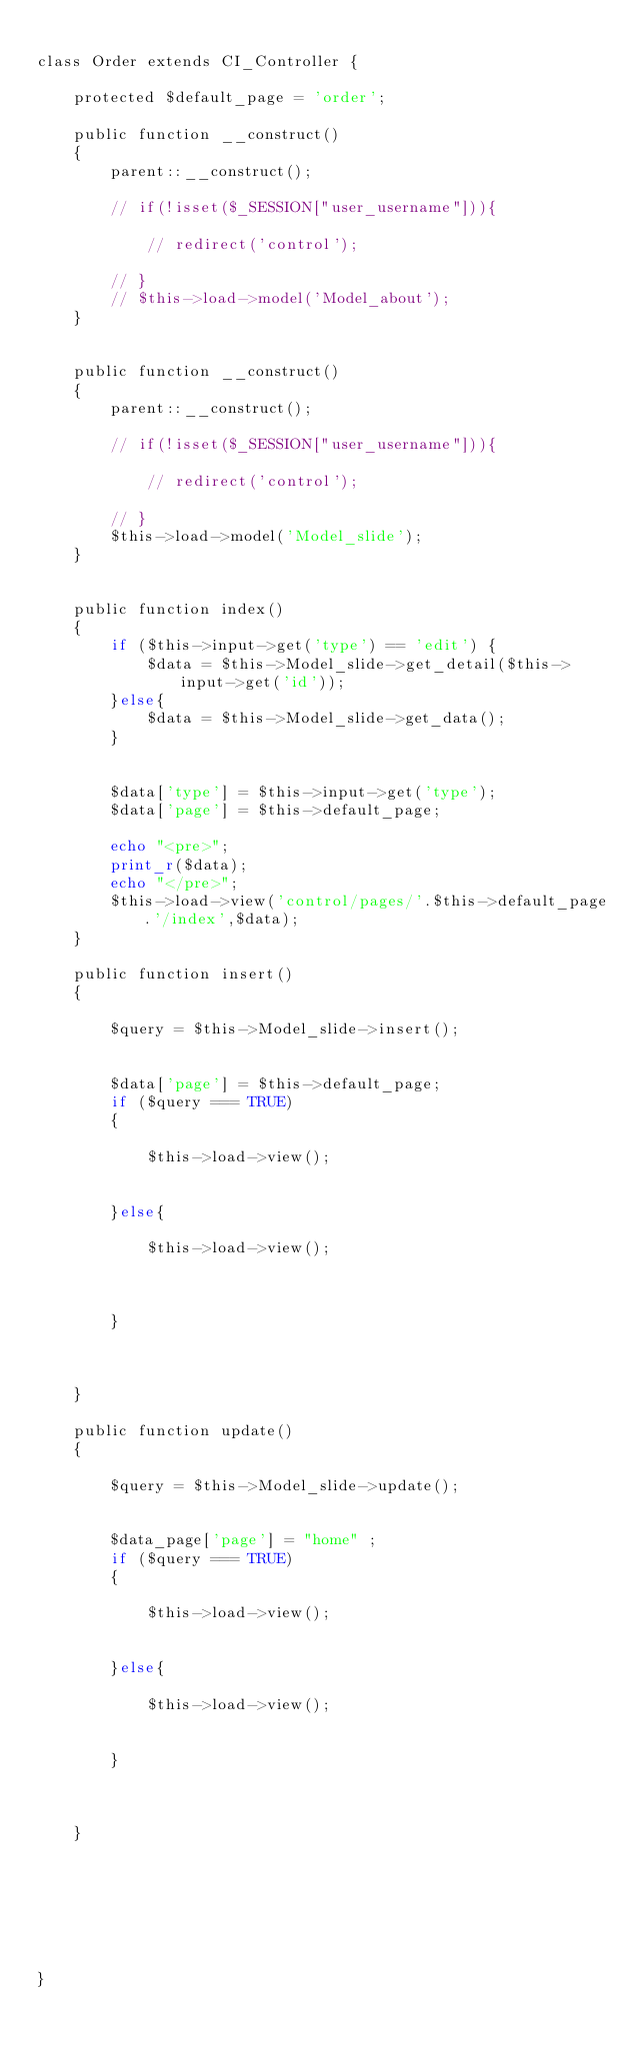Convert code to text. <code><loc_0><loc_0><loc_500><loc_500><_PHP_>
class Order extends CI_Controller {
	
	protected $default_page = 'order';

	public function __construct()
	{
		parent::__construct();		
		
		// if(!isset($_SESSION["user_username"])){

			// redirect('control');  

		// }
		// $this->load->model('Model_about');	
	}

	
	public function __construct()
	{
		parent::__construct();		
		
		// if(!isset($_SESSION["user_username"])){

			// redirect('control');  

		// }
		$this->load->model('Model_slide');	
	}

	
	public function index()
	{	
		if ($this->input->get('type') == 'edit') {
			$data = $this->Model_slide->get_detail($this->input->get('id'));
		}else{
			$data = $this->Model_slide->get_data();
		}

		
		$data['type'] = $this->input->get('type');
		$data['page'] = $this->default_page;		

		echo "<pre>";
		print_r($data);
		echo "</pre>";
		$this->load->view('control/pages/'.$this->default_page.'/index',$data);
	}
	
	public function insert()
	{
		
		$query = $this->Model_slide->insert();
		
		
		$data['page'] = $this->default_page;
		if ($query === TRUE)
		{

			$this->load->view();
			

		}else{
			
			$this->load->view();
			


		}
		
		
		
	}

	public function update()
	{
		
		$query = $this->Model_slide->update();
		
		
		$data_page['page'] = "home" ;
		if ($query === TRUE)
		{
			
			$this->load->view();
			

		}else{
			
			$this->load->view();
			

		}
		
		
		
	}
	
	
	
	
	
	
	
}
</code> 